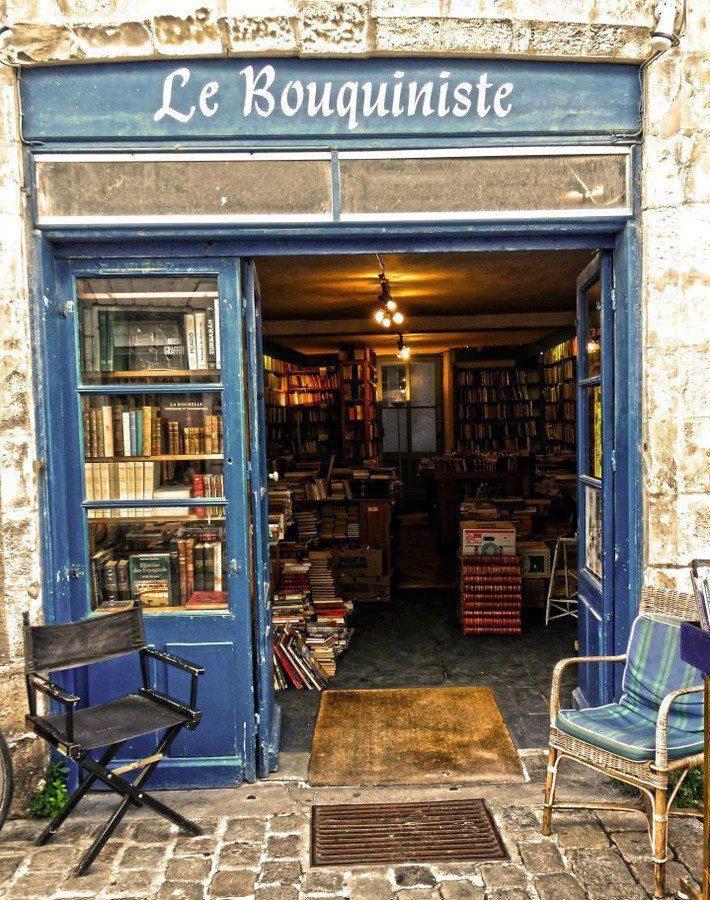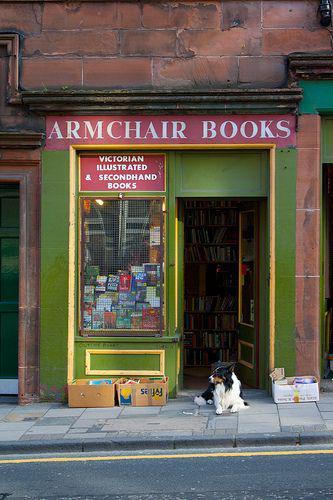The first image is the image on the left, the second image is the image on the right. For the images shown, is this caption "One storefront has light stone bordering around wood that is painted navy blue." true? Answer yes or no. Yes. The first image is the image on the left, the second image is the image on the right. Given the left and right images, does the statement "There are at least two cardboard boxes of books on the pavement outside the book shop." hold true? Answer yes or no. Yes. 